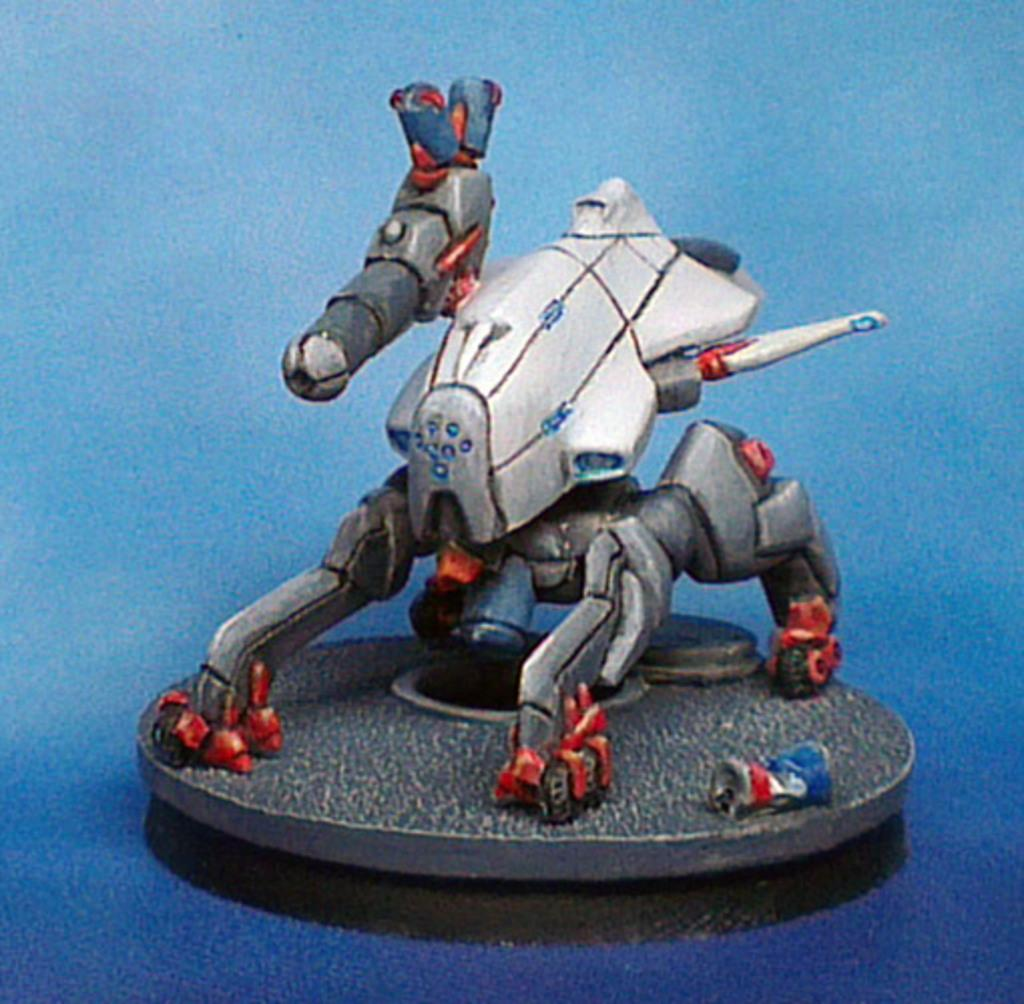What is the main object in the image? There is a toy in the image. Where is the toy located? The toy is on an object. What color is the background of the image? The background of the image is blue in color. What is the purpose of the water in the image? There is no water present in the image, so it cannot serve any purpose. 